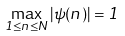Convert formula to latex. <formula><loc_0><loc_0><loc_500><loc_500>\max _ { 1 \leq n \leq N } | \psi ( n ) | = 1</formula> 